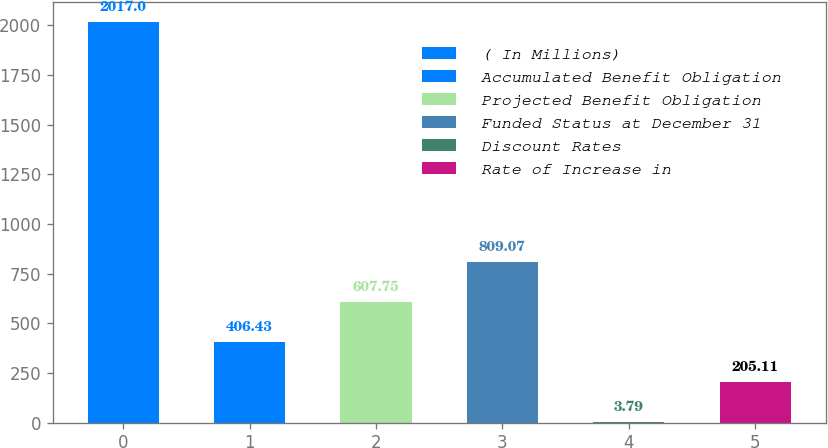<chart> <loc_0><loc_0><loc_500><loc_500><bar_chart><fcel>( In Millions)<fcel>Accumulated Benefit Obligation<fcel>Projected Benefit Obligation<fcel>Funded Status at December 31<fcel>Discount Rates<fcel>Rate of Increase in<nl><fcel>2017<fcel>406.43<fcel>607.75<fcel>809.07<fcel>3.79<fcel>205.11<nl></chart> 